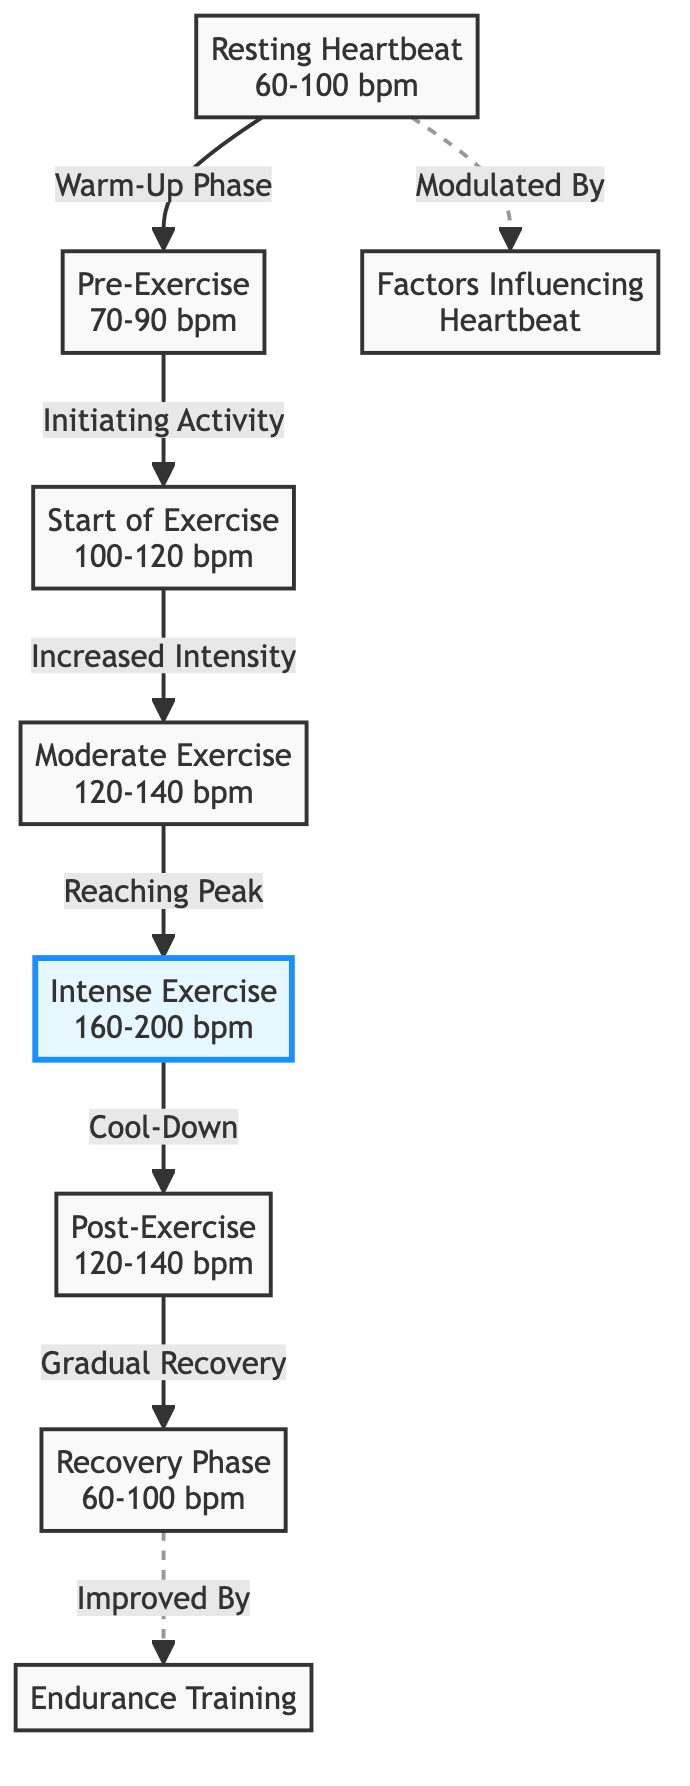What is the resting heartbeat range? The diagram shows the "Resting Heartbeat" node clearly labeled with a value range of 60-100 bpm. This value is specified directly in the node and reflects the rate at which the heart beats while at rest.
Answer: 60-100 bpm What phase comes after the "Start of Exercise"? In the sequence of the diagram, "Start of Exercise" is followed by "Moderate Exercise." Therefore, the transition from one phase to the next indicates that once exercise starts, the intensity increases to a moderate level.
Answer: Moderate Exercise What is the heartbeat range during "Intense Exercise"? The "Intense Exercise" node indicates a heartbeat range of 160-200 bpm. This value is directly provided within the node of the diagram, representing the exertion level during that phase.
Answer: 160-200 bpm Which phase follows "Post-Exercise"? According to the diagram, after "Post-Exercise," the next phase is "Recovery Phase." This transition showcases the heart rate's change following physical exertion as the body begins to recover.
Answer: Recovery Phase How many phases of heart activity are listed in the diagram? The diagram contains a total of seven distinct phases of heart activity from "Resting Heartbeat" to "Recovery Phase." Each of these nodes represents a unique state in the heart's activity during exercise and recovery.
Answer: 7 What node highlights the peak performance heart rate? In the diagram, the node "Intense Exercise" is specifically highlighted, indicating that this stage corresponds to peak performance heart rate during the exercise workflow.
Answer: Intense Exercise What phrase indicates that recovery can be enhanced by training? The phrase "Improved By" near the "Recovery Phase" node indicates the influence of "Endurance Training," suggesting that such training can lead to a better recovery phase.
Answer: Improved By What is the relationship indicated between "Resting Heartbeat" and "Factors Influencing Heartbeat"? The relationship indicated by a dashed line implies that the resting heartbeat is modulated by various factors, suggesting external or internal influences can affect heart rate at rest.
Answer: Modulated By 